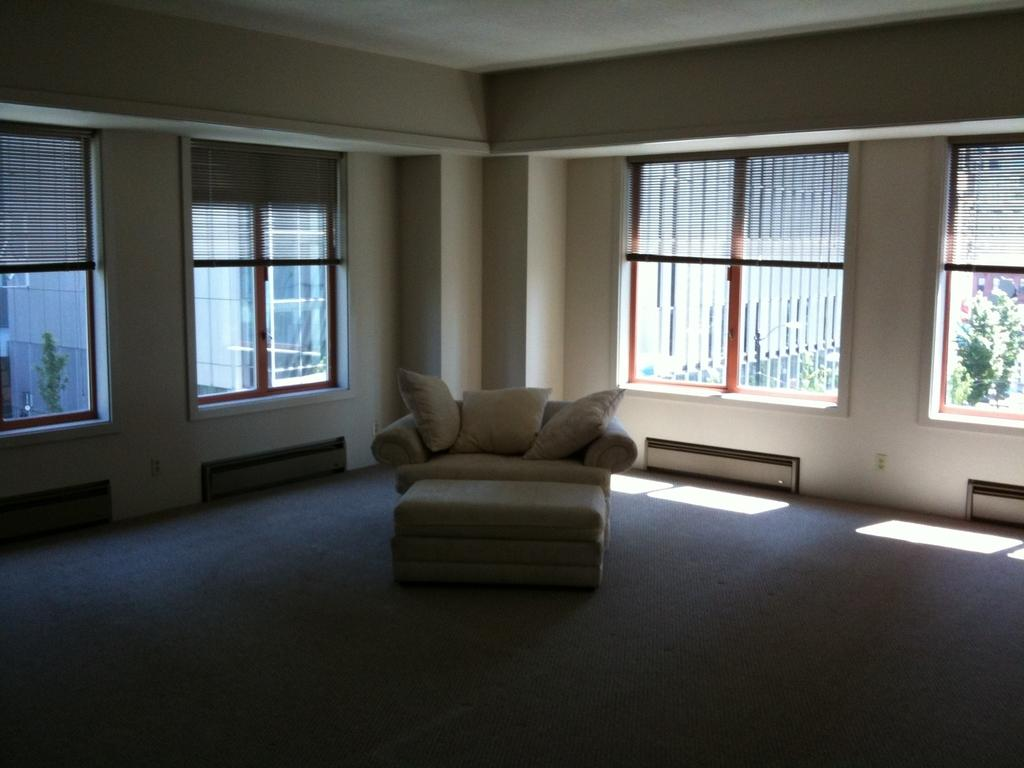What is the color of the wall in the image? The wall in the image is white. What can be seen on the wall in the image? There are windows visible on the wall in the image. What is visible outside the windows in the image? There is a building visible outside the windows in the image. What type of furniture is present in the room in the image? There is a white color sofa in the image. What type of decorative items are present on the sofa in the image? There are white color pillows in the image. What type of bird is sitting on the chain in the image? There is no bird or chain present in the image. What is being transported in the crate in the image? There is no crate present in the image. 